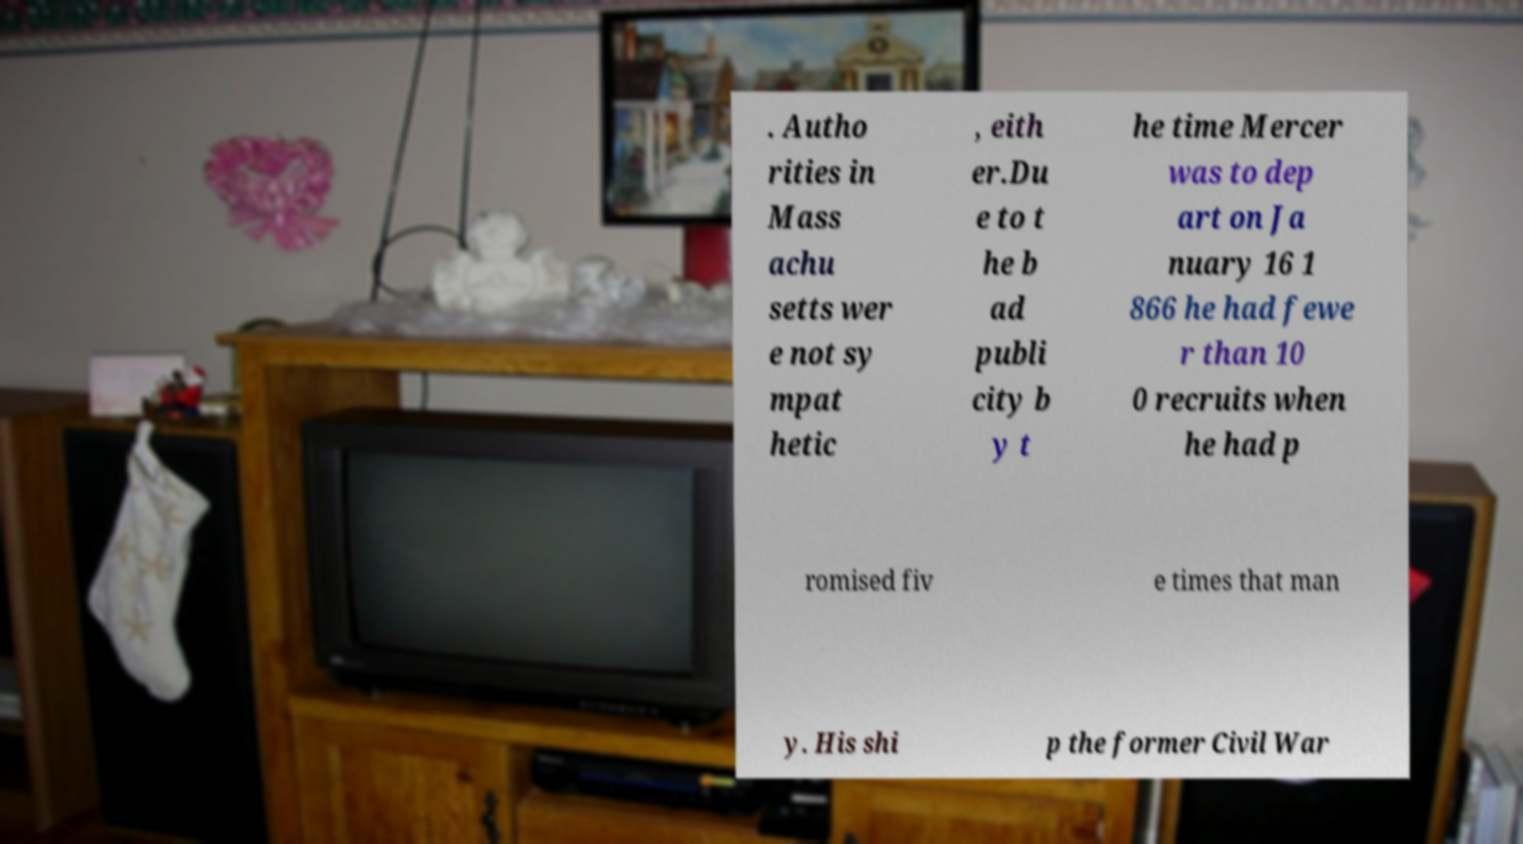Can you read and provide the text displayed in the image?This photo seems to have some interesting text. Can you extract and type it out for me? . Autho rities in Mass achu setts wer e not sy mpat hetic , eith er.Du e to t he b ad publi city b y t he time Mercer was to dep art on Ja nuary 16 1 866 he had fewe r than 10 0 recruits when he had p romised fiv e times that man y. His shi p the former Civil War 